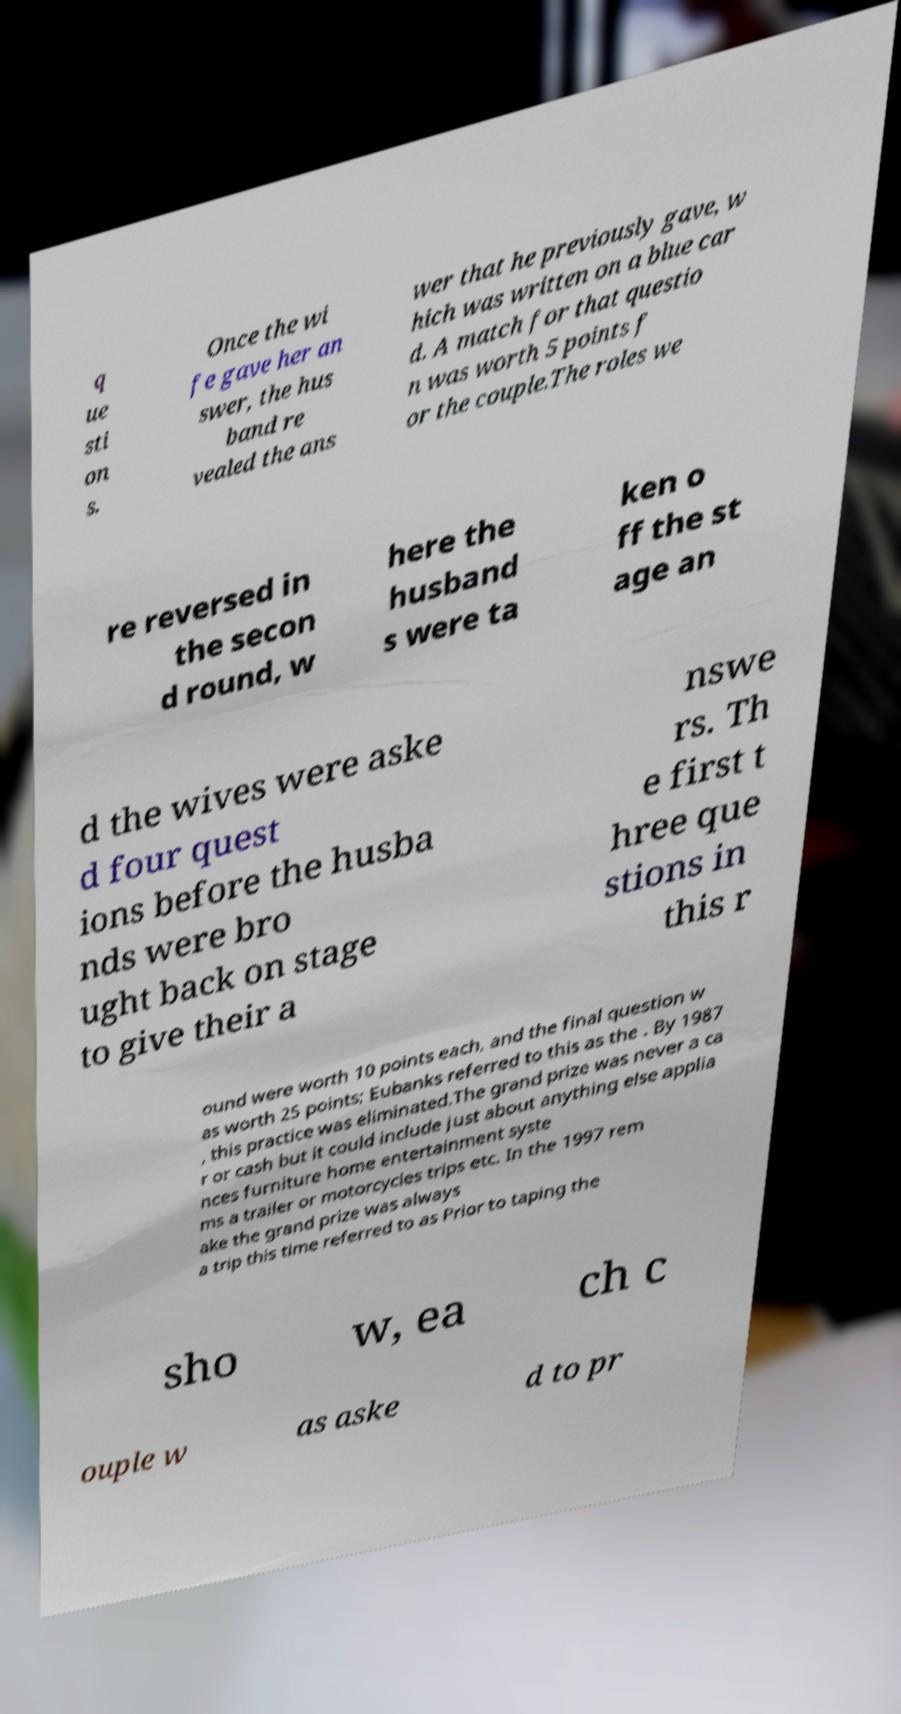Could you extract and type out the text from this image? q ue sti on s. Once the wi fe gave her an swer, the hus band re vealed the ans wer that he previously gave, w hich was written on a blue car d. A match for that questio n was worth 5 points f or the couple.The roles we re reversed in the secon d round, w here the husband s were ta ken o ff the st age an d the wives were aske d four quest ions before the husba nds were bro ught back on stage to give their a nswe rs. Th e first t hree que stions in this r ound were worth 10 points each, and the final question w as worth 25 points; Eubanks referred to this as the . By 1987 , this practice was eliminated.The grand prize was never a ca r or cash but it could include just about anything else applia nces furniture home entertainment syste ms a trailer or motorcycles trips etc. In the 1997 rem ake the grand prize was always a trip this time referred to as Prior to taping the sho w, ea ch c ouple w as aske d to pr 